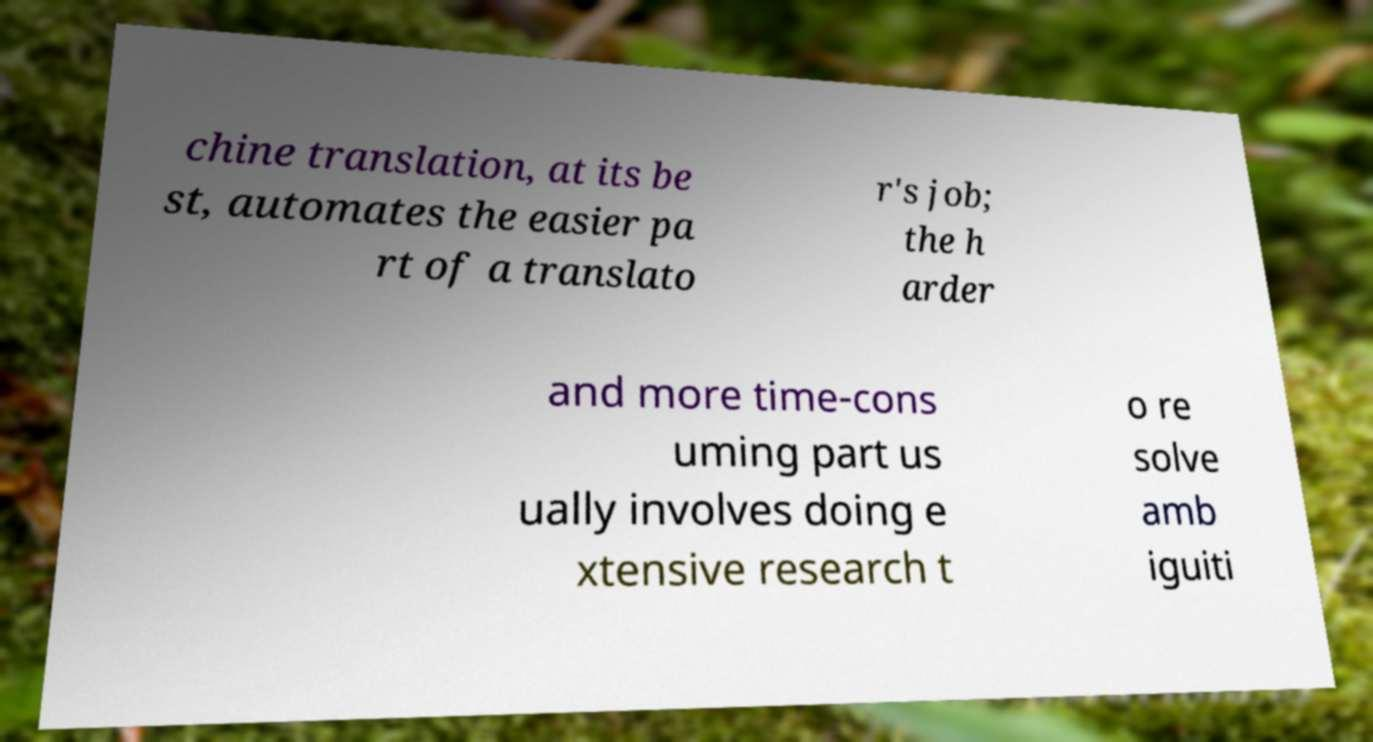Please identify and transcribe the text found in this image. chine translation, at its be st, automates the easier pa rt of a translato r's job; the h arder and more time-cons uming part us ually involves doing e xtensive research t o re solve amb iguiti 